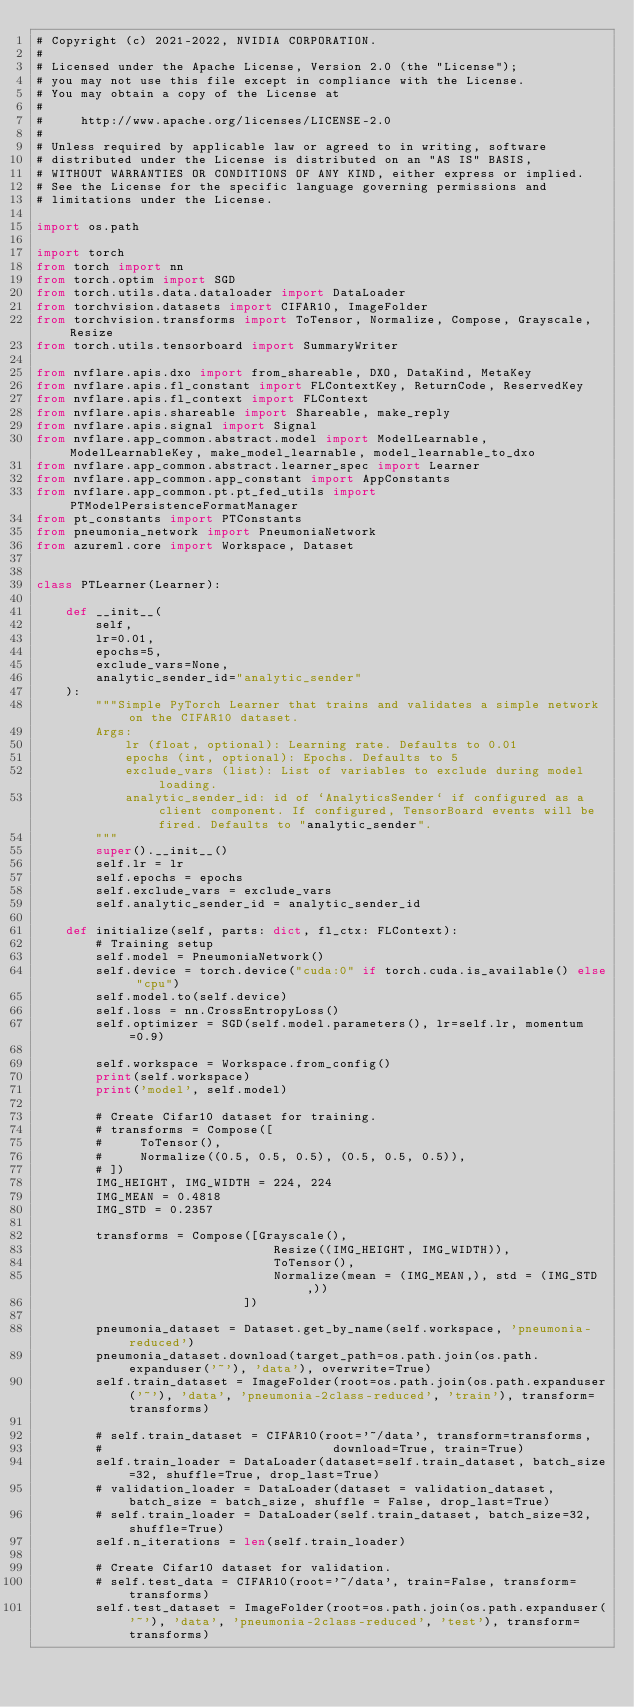Convert code to text. <code><loc_0><loc_0><loc_500><loc_500><_Python_># Copyright (c) 2021-2022, NVIDIA CORPORATION.
#
# Licensed under the Apache License, Version 2.0 (the "License");
# you may not use this file except in compliance with the License.
# You may obtain a copy of the License at
#
#     http://www.apache.org/licenses/LICENSE-2.0
#
# Unless required by applicable law or agreed to in writing, software
# distributed under the License is distributed on an "AS IS" BASIS,
# WITHOUT WARRANTIES OR CONDITIONS OF ANY KIND, either express or implied.
# See the License for the specific language governing permissions and
# limitations under the License.

import os.path

import torch
from torch import nn
from torch.optim import SGD
from torch.utils.data.dataloader import DataLoader
from torchvision.datasets import CIFAR10, ImageFolder
from torchvision.transforms import ToTensor, Normalize, Compose, Grayscale, Resize
from torch.utils.tensorboard import SummaryWriter

from nvflare.apis.dxo import from_shareable, DXO, DataKind, MetaKey
from nvflare.apis.fl_constant import FLContextKey, ReturnCode, ReservedKey
from nvflare.apis.fl_context import FLContext
from nvflare.apis.shareable import Shareable, make_reply
from nvflare.apis.signal import Signal
from nvflare.app_common.abstract.model import ModelLearnable, ModelLearnableKey, make_model_learnable, model_learnable_to_dxo
from nvflare.app_common.abstract.learner_spec import Learner
from nvflare.app_common.app_constant import AppConstants
from nvflare.app_common.pt.pt_fed_utils import PTModelPersistenceFormatManager
from pt_constants import PTConstants
from pneumonia_network import PneumoniaNetwork
from azureml.core import Workspace, Dataset


class PTLearner(Learner):

    def __init__(
        self,
        lr=0.01,
        epochs=5,
        exclude_vars=None,
        analytic_sender_id="analytic_sender"
    ):
        """Simple PyTorch Learner that trains and validates a simple network on the CIFAR10 dataset.
        Args:
            lr (float, optional): Learning rate. Defaults to 0.01
            epochs (int, optional): Epochs. Defaults to 5
            exclude_vars (list): List of variables to exclude during model loading.
            analytic_sender_id: id of `AnalyticsSender` if configured as a client component. If configured, TensorBoard events will be fired. Defaults to "analytic_sender".
        """
        super().__init__()
        self.lr = lr
        self.epochs = epochs
        self.exclude_vars = exclude_vars
        self.analytic_sender_id = analytic_sender_id

    def initialize(self, parts: dict, fl_ctx: FLContext):
        # Training setup
        self.model = PneumoniaNetwork()
        self.device = torch.device("cuda:0" if torch.cuda.is_available() else "cpu")
        self.model.to(self.device)
        self.loss = nn.CrossEntropyLoss()
        self.optimizer = SGD(self.model.parameters(), lr=self.lr, momentum=0.9)

        self.workspace = Workspace.from_config()
        print(self.workspace)
        print('model', self.model)

        # Create Cifar10 dataset for training.
        # transforms = Compose([
        #     ToTensor(),
        #     Normalize((0.5, 0.5, 0.5), (0.5, 0.5, 0.5)),
        # ])
        IMG_HEIGHT, IMG_WIDTH = 224, 224
        IMG_MEAN = 0.4818
        IMG_STD = 0.2357

        transforms = Compose([Grayscale(),
                                Resize((IMG_HEIGHT, IMG_WIDTH)),
                                ToTensor(),
                                Normalize(mean = (IMG_MEAN,), std = (IMG_STD,))    
                            ])

        pneumonia_dataset = Dataset.get_by_name(self.workspace, 'pneumonia-reduced')
        pneumonia_dataset.download(target_path=os.path.join(os.path.expanduser('~'), 'data'), overwrite=True)
        self.train_dataset = ImageFolder(root=os.path.join(os.path.expanduser('~'), 'data', 'pneumonia-2class-reduced', 'train'), transform=transforms)

        # self.train_dataset = CIFAR10(root='~/data', transform=transforms,
        #                               download=True, train=True)
        self.train_loader = DataLoader(dataset=self.train_dataset, batch_size=32, shuffle=True, drop_last=True)
        # validation_loader = DataLoader(dataset = validation_dataset, batch_size = batch_size, shuffle = False, drop_last=True)
        # self.train_loader = DataLoader(self.train_dataset, batch_size=32, shuffle=True)
        self.n_iterations = len(self.train_loader)

        # Create Cifar10 dataset for validation.
        # self.test_data = CIFAR10(root='~/data', train=False, transform=transforms)
        self.test_dataset = ImageFolder(root=os.path.join(os.path.expanduser('~'), 'data', 'pneumonia-2class-reduced', 'test'), transform=transforms)</code> 